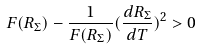<formula> <loc_0><loc_0><loc_500><loc_500>F ( R _ { \Sigma } ) - \frac { 1 } { F ( R _ { \Sigma } ) } ( \frac { d R _ { \Sigma } } { d T } ) ^ { 2 } > 0</formula> 